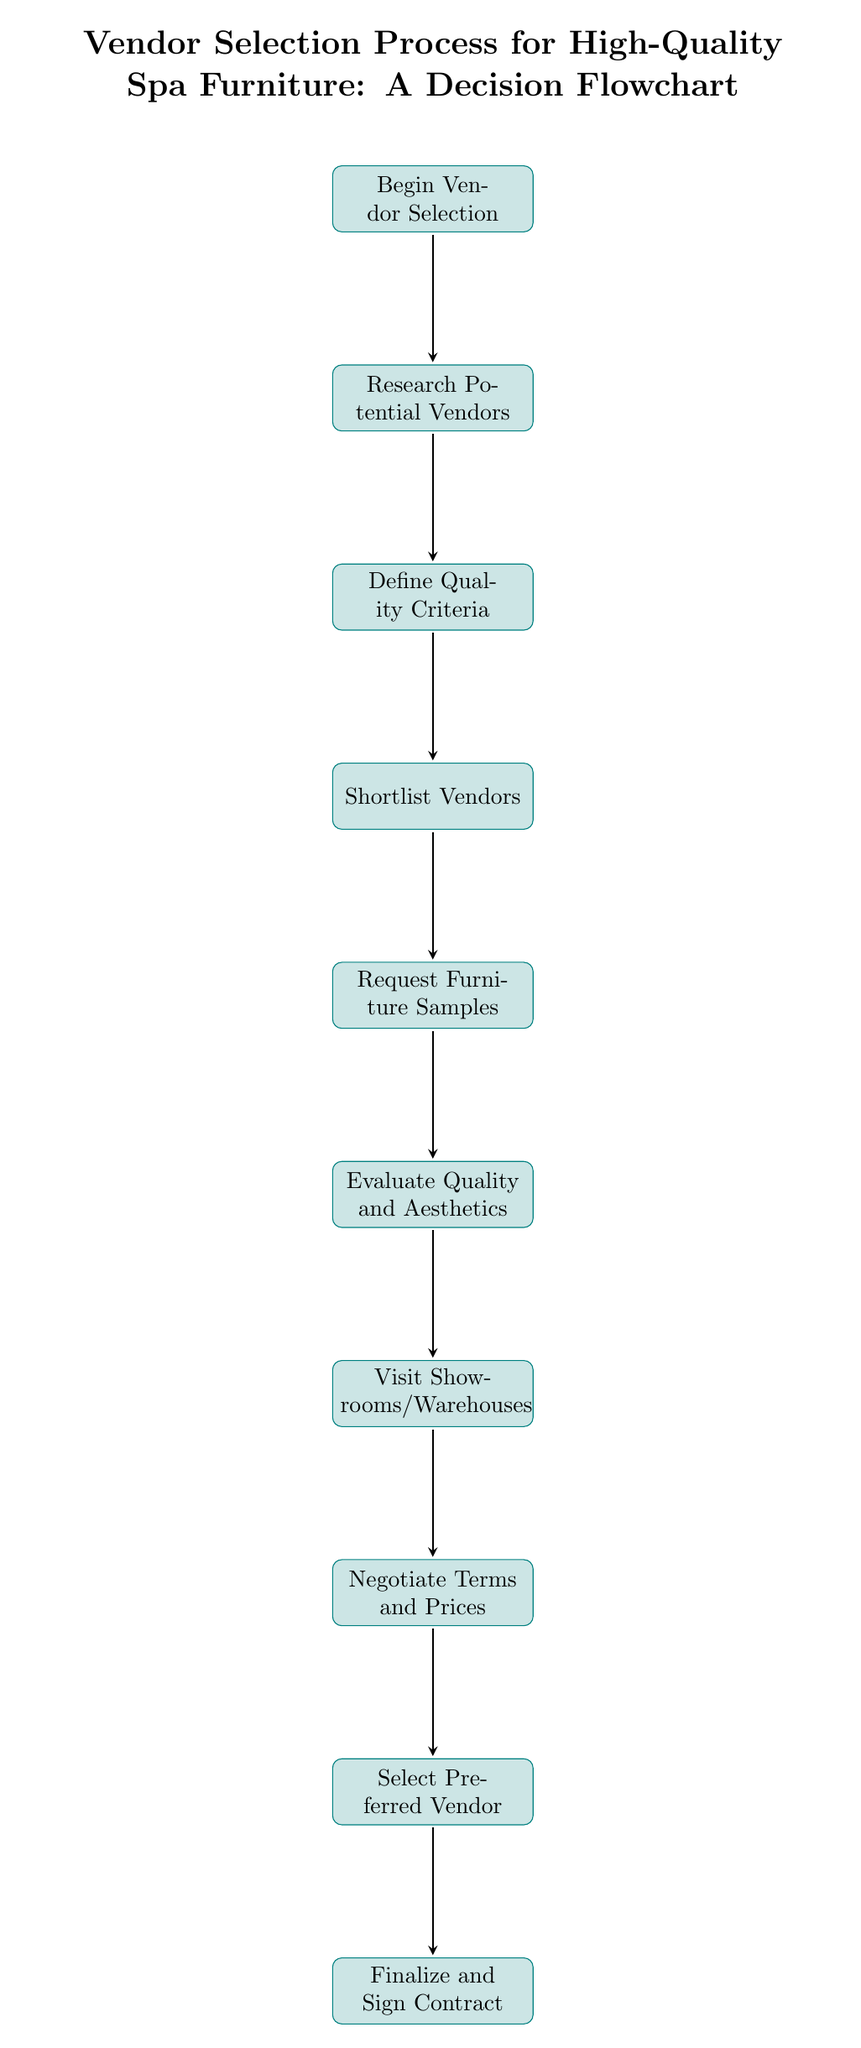What is the first step in the vendor selection process? The first step in the flowchart is indicated by the top node labeled "Begin Vendor Selection". This is the starting point of the entire process, and each subsequent step follows from it.
Answer: Begin Vendor Selection How many total steps are in the vendor selection process? By counting the individual nodes in the flowchart, we find there are 10 distinct steps from "Begin Vendor Selection" to "Finalize and Sign Contract". This number includes all the processes outlined in the diagram.
Answer: 10 What is the last action in the vendor selection process? The last action is labeled "Finalize and Sign Contract", which is the final step after selecting the preferred vendor and negotiating terms. It indicates the completion of the selection process.
Answer: Finalize and Sign Contract Which step occurs after 'Request Furniture Samples'? According to the flowchart, the step that follows "Request Furniture Samples" is "Evaluate Quality and Aesthetics". This indicates a logical progression where after obtaining samples, the quality and aesthetics are assessed.
Answer: Evaluate Quality and Aesthetics What is the relationship between 'Shortlist Vendors' and 'Negotiate Terms and Prices'? The relationship is sequential, as "Shortlist Vendors" must be completed before moving on to "Negotiate Terms and Prices". Each step in the flowchart represents a necessary progression, and this implies that you cannot negotiate terms without first identifying a shortlist of vendors.
Answer: Sequential relationship 